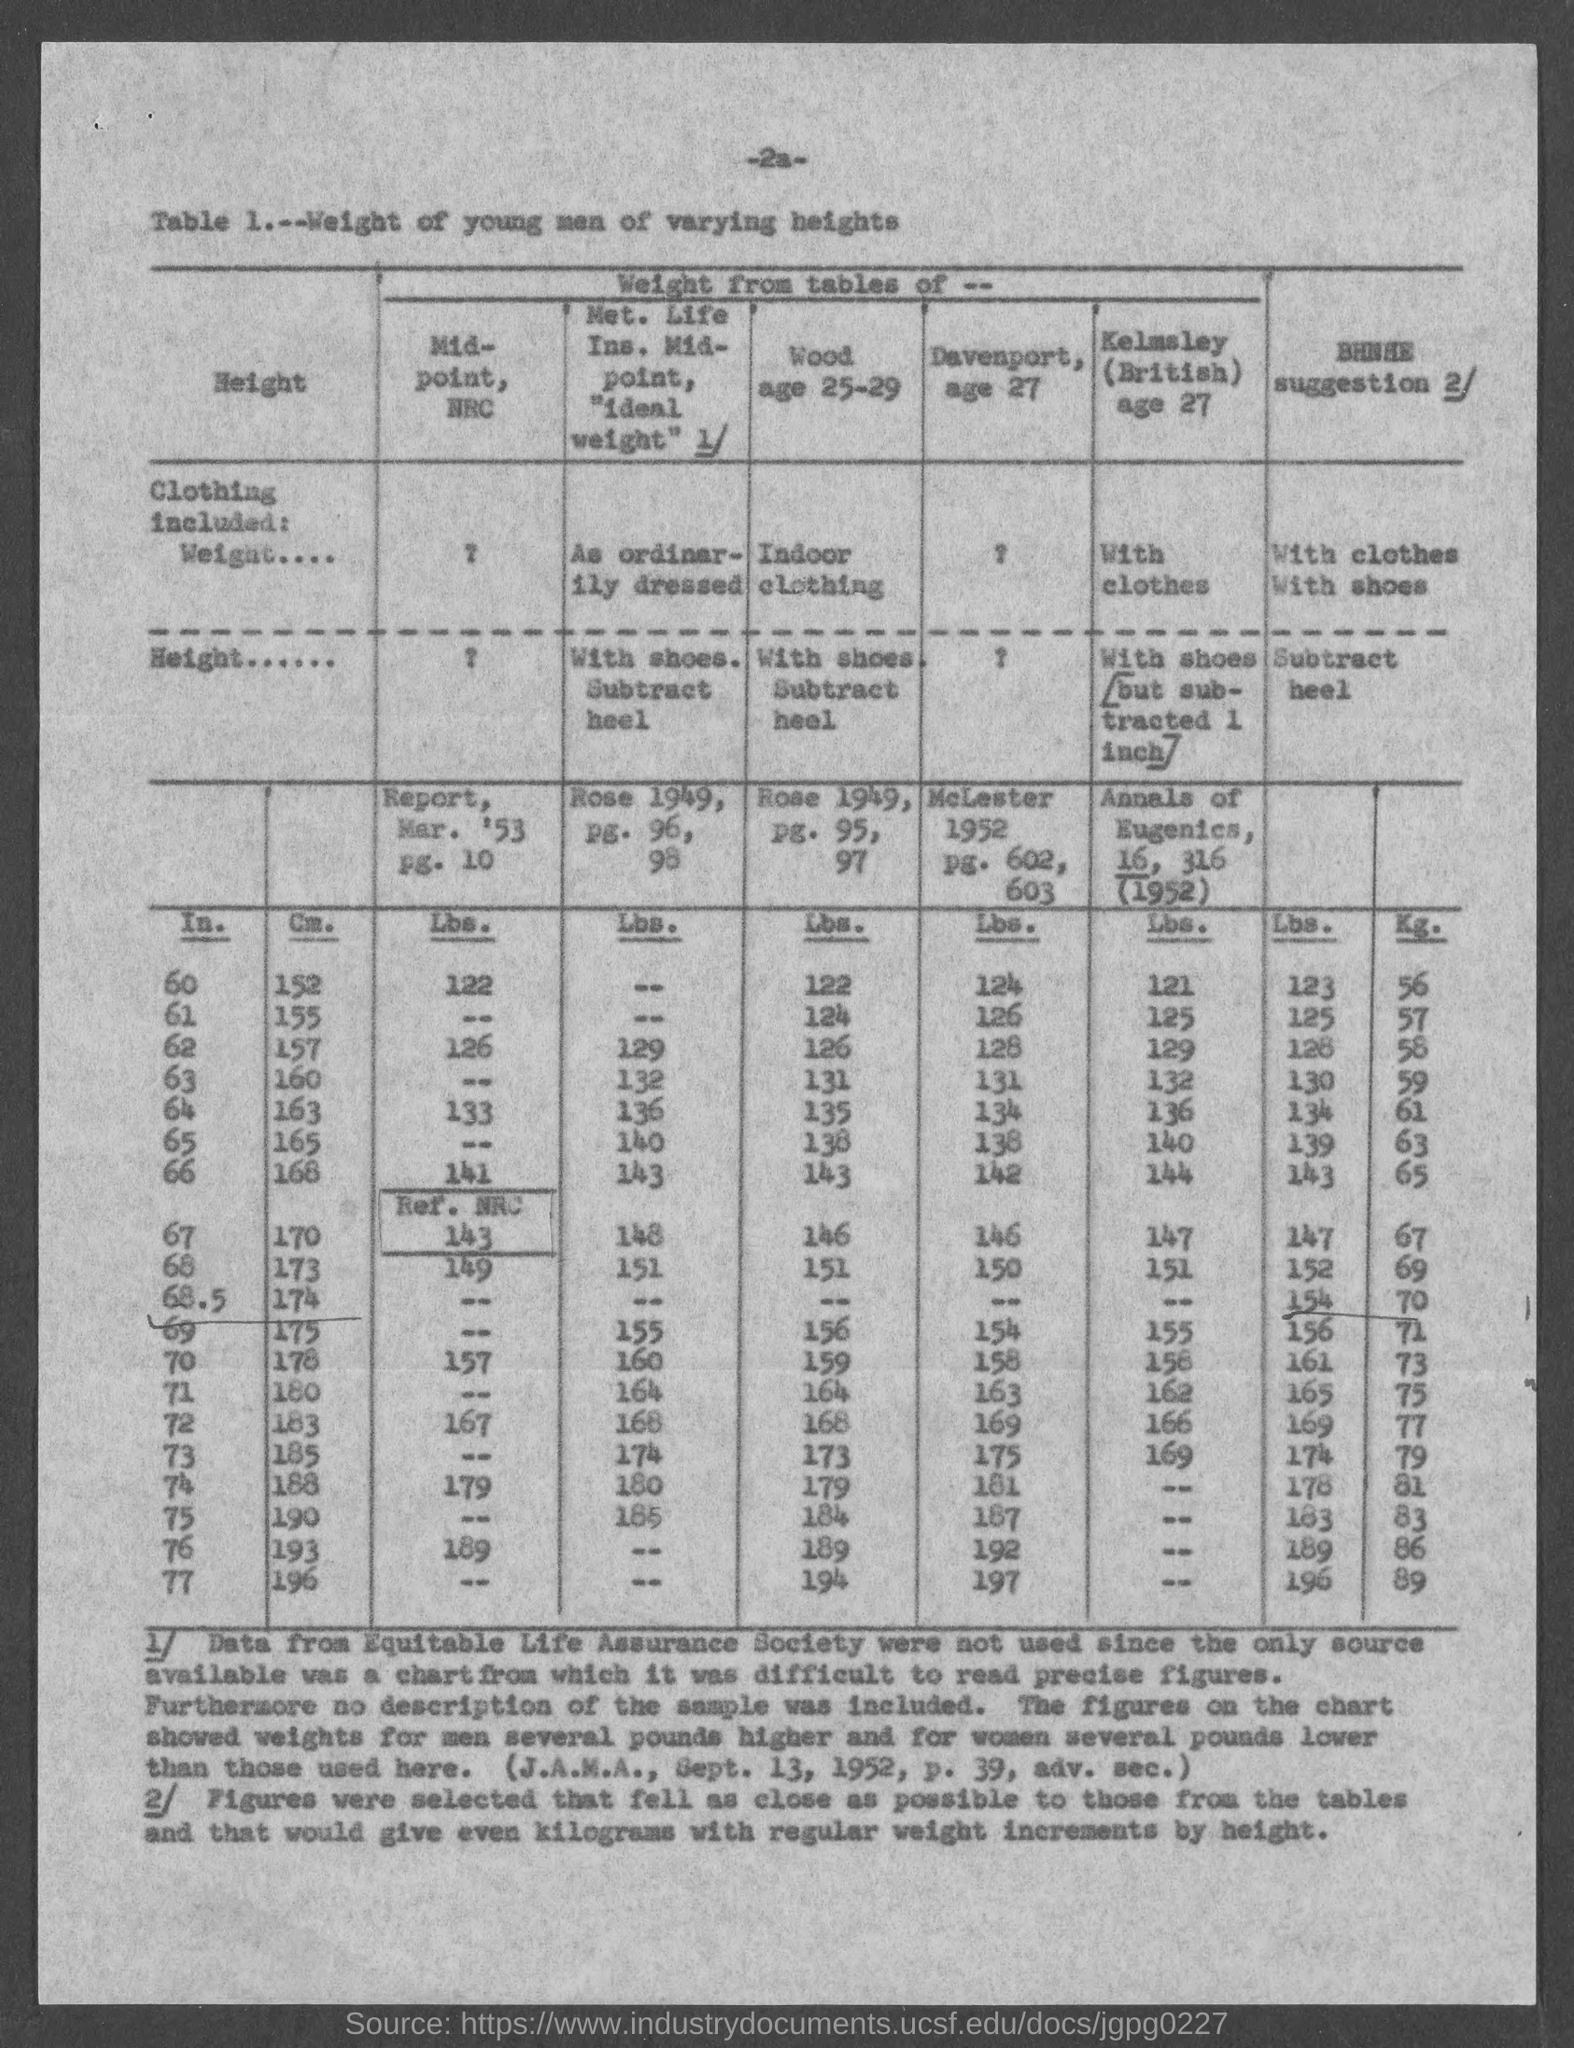Give some essential details in this illustration. The data that was not used in this study came from the Equitable Life Assurance Society. 